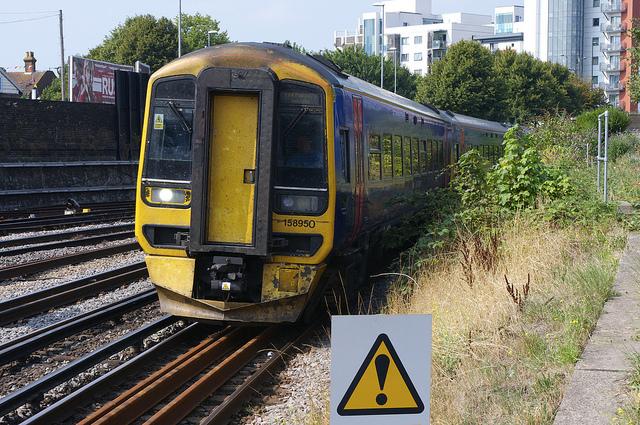Does the train have a face?
Be succinct. No. What color is the light?
Write a very short answer. White. What punctuation mark is on the sign inside the triangle?
Be succinct. Exclamation. How many warning signs?
Give a very brief answer. 1. How many lights on the train are turned on?
Answer briefly. 1. 